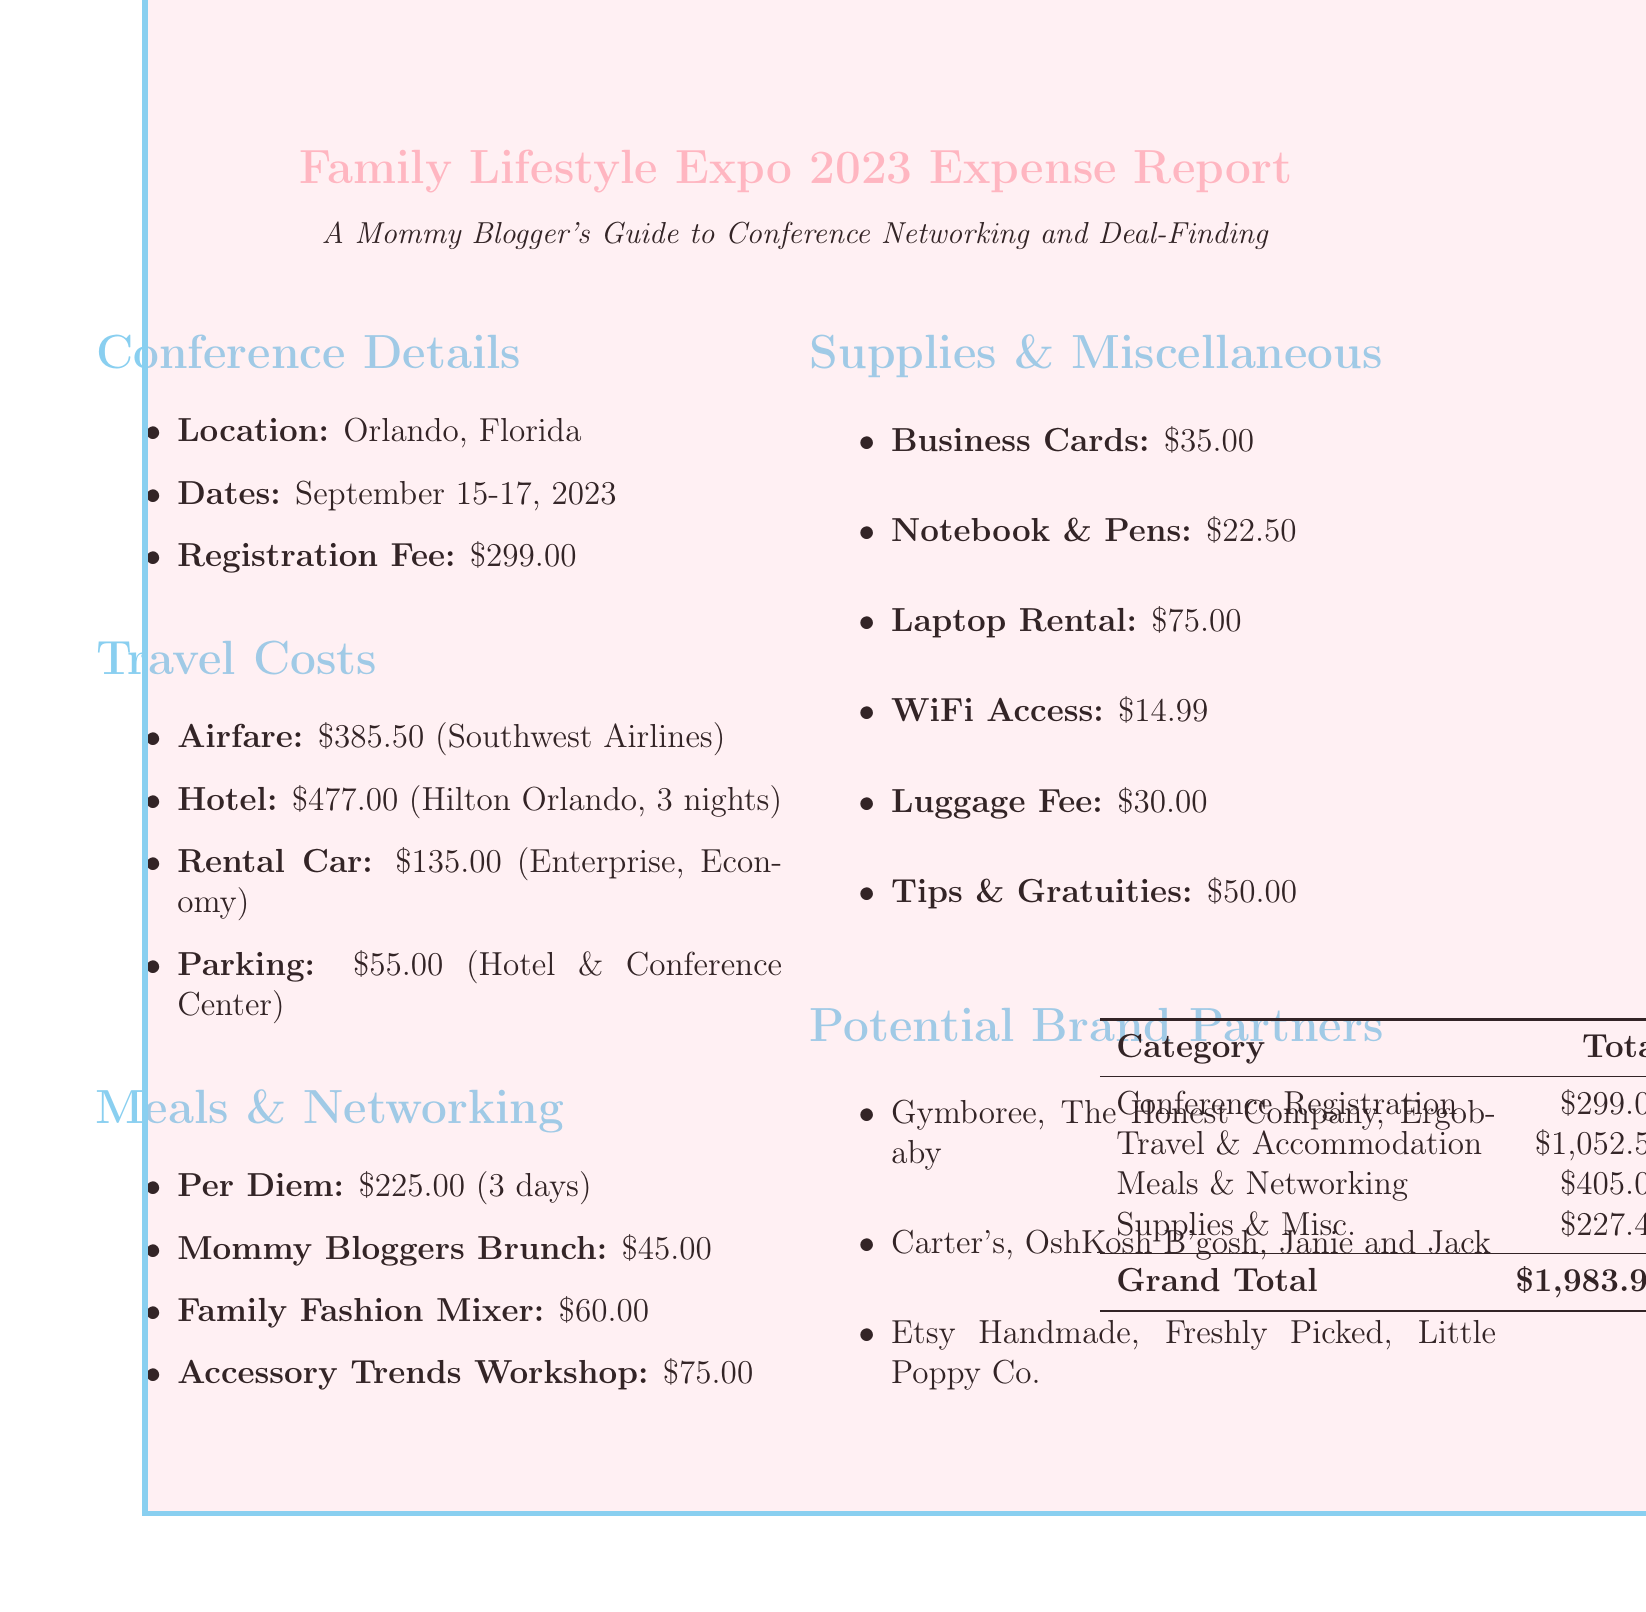What is the registration fee? The document states that the registration fee for the conference is $299.00.
Answer: $299.00 What were the accommodation costs? The total accommodation cost for three nights at the Hilton Orlando is detailed in the travel costs section.
Answer: $477.00 How much was spent on meals per day? The document specifies a per diem amount allocated for meals, which is $75.00 per day for three days.
Answer: $75.00 What is the total cost for networking events? The total cost for the three networking events listed in the document can be calculated by summing their individual costs.
Answer: $180.00 What brand partners were present at the Accessory Trends Workshop? The brands found as potential partners at the Accessory Trends Workshop are mentioned in the networking events section.
Answer: Etsy Handmade, Freshly Picked, Little Poppy Co How much was spent on miscellaneous expenses? The miscellaneous section lists various expenses that contribute to the total miscellaneous costs.
Answer: $104.99 Which airline was used for airfare? The document specifies that Southwest Airlines was the airline used for the airfare.
Answer: Southwest Airlines What is the total travel and accommodation cost? This can be calculated by accumulating the airfare, total accommodation, rental car, and parking costs detailed in the document.
Answer: $1,052.50 How many nights was the accommodation booked for? The document states the number of nights booked at the hotel, which can be directly found in the travel costs section.
Answer: 3 